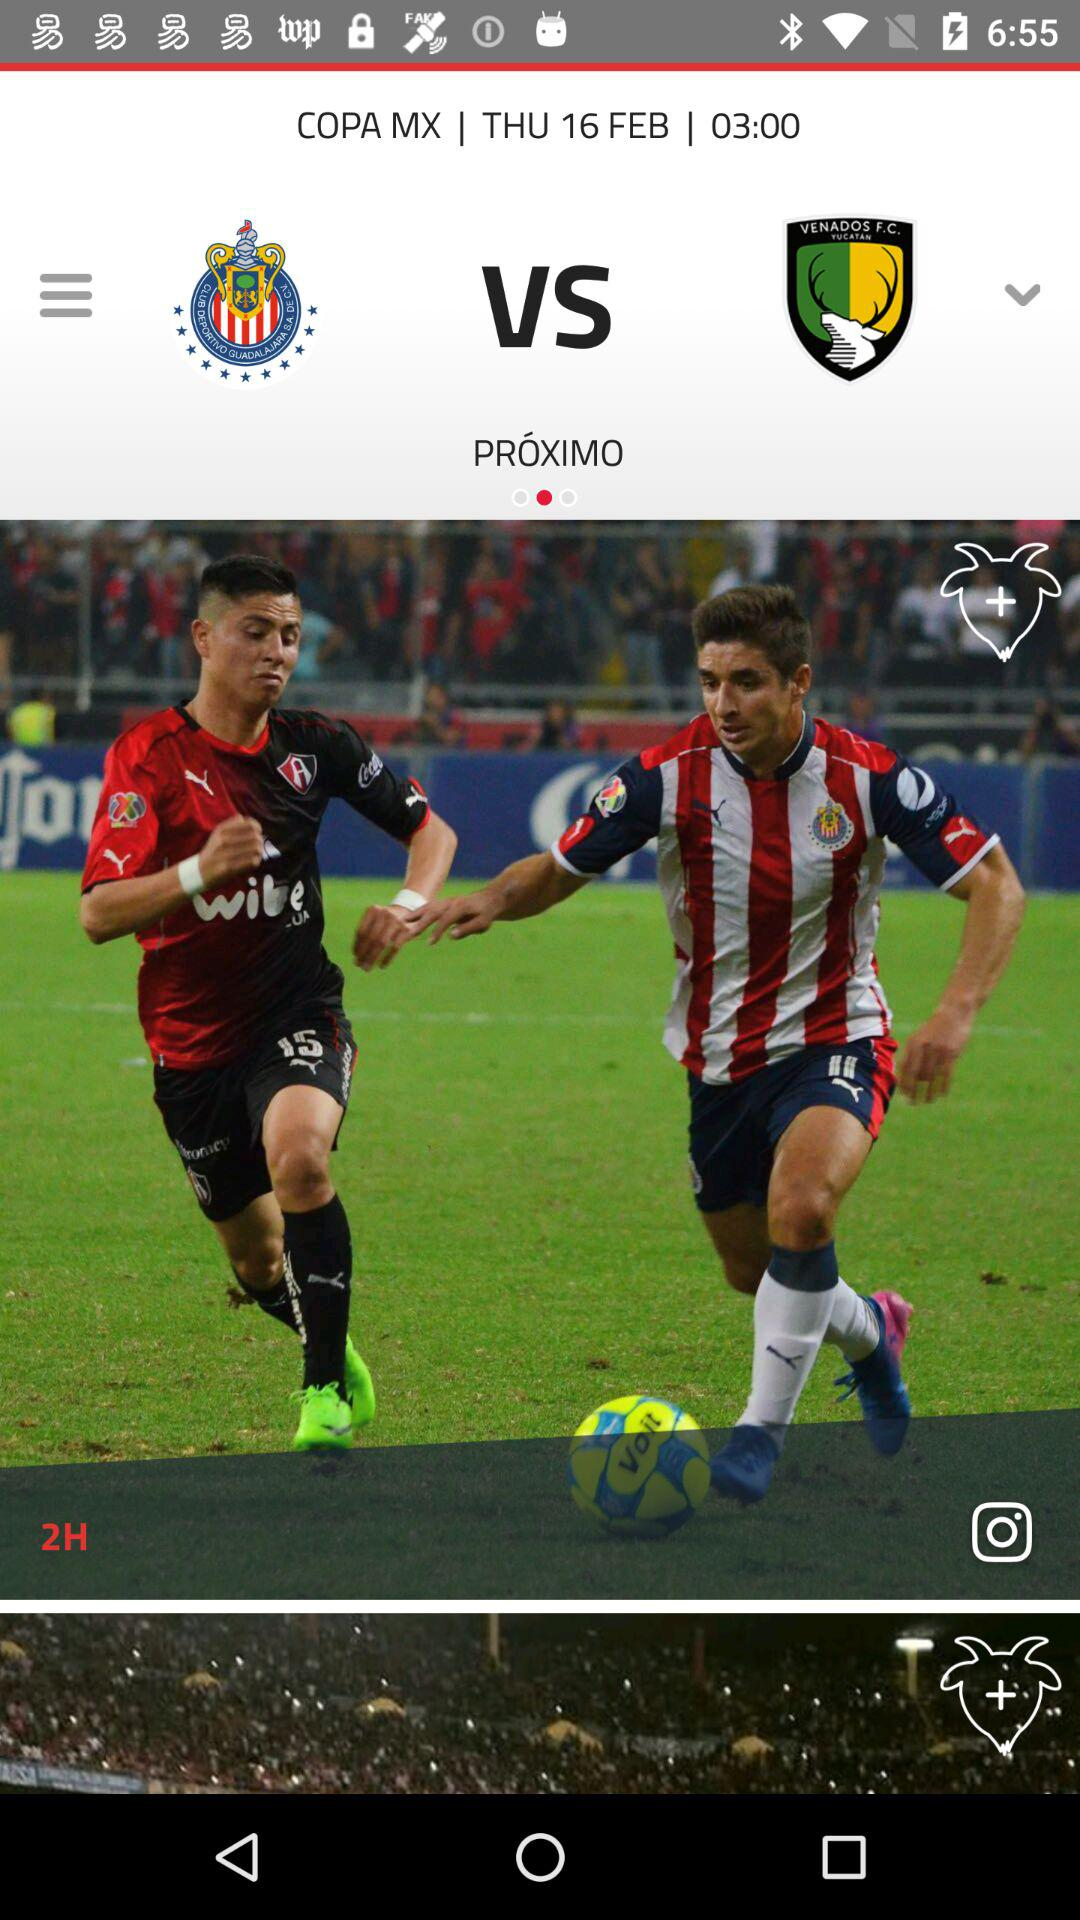How many hours until the next game?
Answer the question using a single word or phrase. 2 